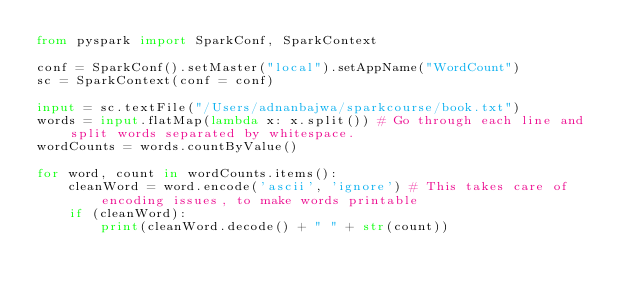<code> <loc_0><loc_0><loc_500><loc_500><_Python_>from pyspark import SparkConf, SparkContext

conf = SparkConf().setMaster("local").setAppName("WordCount")
sc = SparkContext(conf = conf)

input = sc.textFile("/Users/adnanbajwa/sparkcourse/book.txt")
words = input.flatMap(lambda x: x.split()) # Go through each line and split words separated by whitespace. 
wordCounts = words.countByValue()

for word, count in wordCounts.items():
    cleanWord = word.encode('ascii', 'ignore') # This takes care of encoding issues, to make words printable
    if (cleanWord):
        print(cleanWord.decode() + " " + str(count))
</code> 